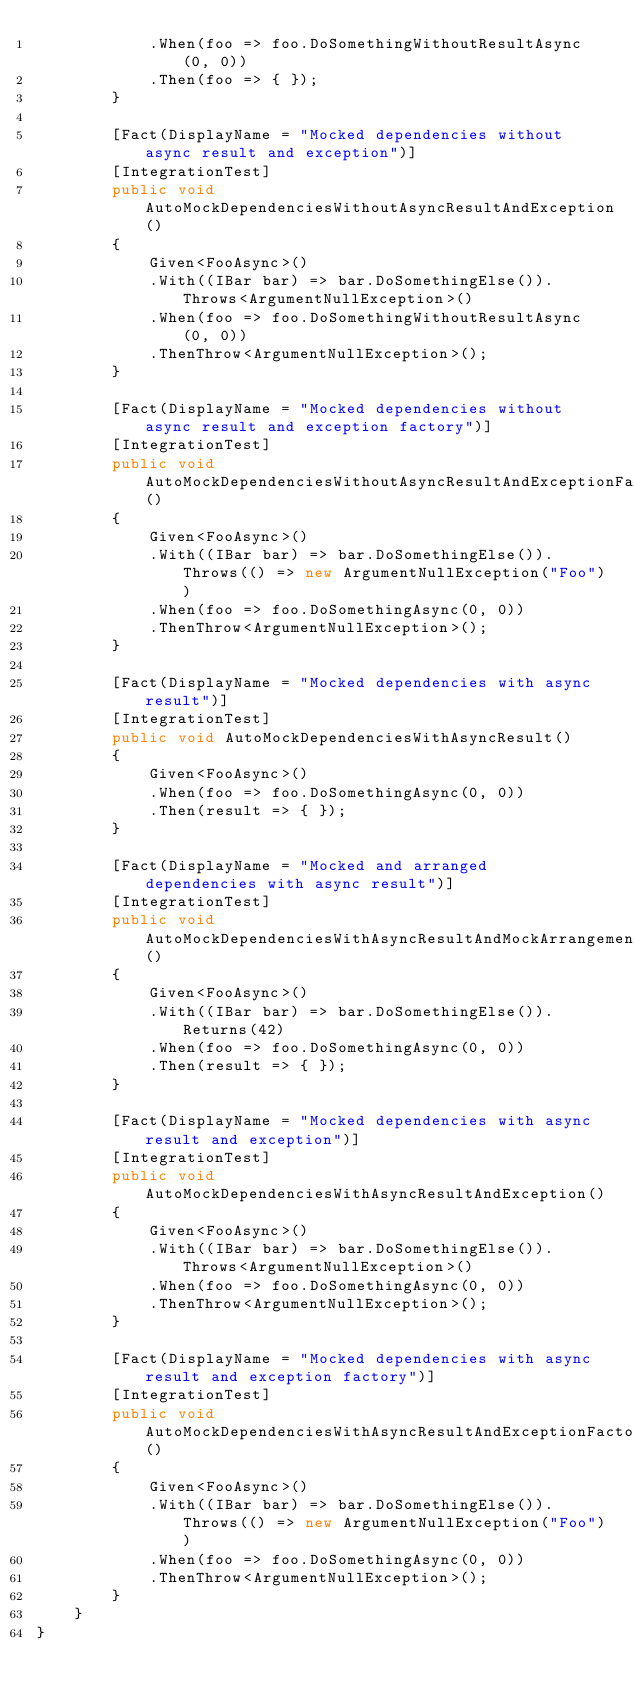<code> <loc_0><loc_0><loc_500><loc_500><_C#_>            .When(foo => foo.DoSomethingWithoutResultAsync(0, 0))
            .Then(foo => { });
        }

        [Fact(DisplayName = "Mocked dependencies without async result and exception")]
        [IntegrationTest]
        public void AutoMockDependenciesWithoutAsyncResultAndException()
        {
            Given<FooAsync>()
            .With((IBar bar) => bar.DoSomethingElse()).Throws<ArgumentNullException>()
            .When(foo => foo.DoSomethingWithoutResultAsync(0, 0))
            .ThenThrow<ArgumentNullException>();
        }

        [Fact(DisplayName = "Mocked dependencies without async result and exception factory")]
        [IntegrationTest]
        public void AutoMockDependenciesWithoutAsyncResultAndExceptionFactory()
        {
            Given<FooAsync>()
            .With((IBar bar) => bar.DoSomethingElse()).Throws(() => new ArgumentNullException("Foo"))
            .When(foo => foo.DoSomethingAsync(0, 0))
            .ThenThrow<ArgumentNullException>();
        }

        [Fact(DisplayName = "Mocked dependencies with async result")]
        [IntegrationTest]
        public void AutoMockDependenciesWithAsyncResult()
        {
            Given<FooAsync>()
            .When(foo => foo.DoSomethingAsync(0, 0))
            .Then(result => { });
        }

        [Fact(DisplayName = "Mocked and arranged dependencies with async result")]
        [IntegrationTest]
        public void AutoMockDependenciesWithAsyncResultAndMockArrangement()
        {
            Given<FooAsync>()
            .With((IBar bar) => bar.DoSomethingElse()).Returns(42)
            .When(foo => foo.DoSomethingAsync(0, 0))
            .Then(result => { });
        }

        [Fact(DisplayName = "Mocked dependencies with async result and exception")]
        [IntegrationTest]
        public void AutoMockDependenciesWithAsyncResultAndException()
        {
            Given<FooAsync>()
            .With((IBar bar) => bar.DoSomethingElse()).Throws<ArgumentNullException>()
            .When(foo => foo.DoSomethingAsync(0, 0))
            .ThenThrow<ArgumentNullException>();
        }

        [Fact(DisplayName = "Mocked dependencies with async result and exception factory")]
        [IntegrationTest]
        public void AutoMockDependenciesWithAsyncResultAndExceptionFactory()
        {
            Given<FooAsync>()
            .With((IBar bar) => bar.DoSomethingElse()).Throws(() => new ArgumentNullException("Foo"))
            .When(foo => foo.DoSomethingAsync(0, 0))
            .ThenThrow<ArgumentNullException>();
        }
    }
}</code> 